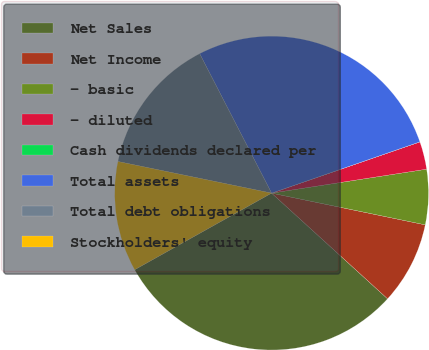<chart> <loc_0><loc_0><loc_500><loc_500><pie_chart><fcel>Net Sales<fcel>Net Income<fcel>- basic<fcel>- diluted<fcel>Cash dividends declared per<fcel>Total assets<fcel>Total debt obligations<fcel>Stockholders' equity<nl><fcel>30.12%<fcel>8.52%<fcel>5.68%<fcel>2.85%<fcel>0.01%<fcel>27.28%<fcel>14.19%<fcel>11.35%<nl></chart> 